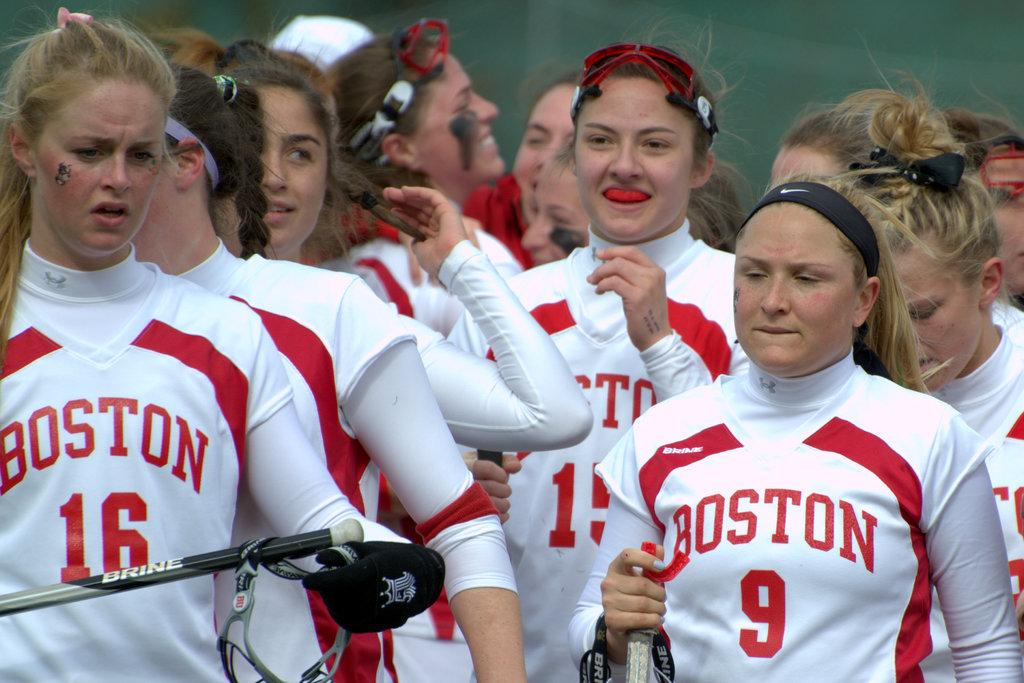<image>
Present a compact description of the photo's key features. a few girls that are wearing Boston uniforms 